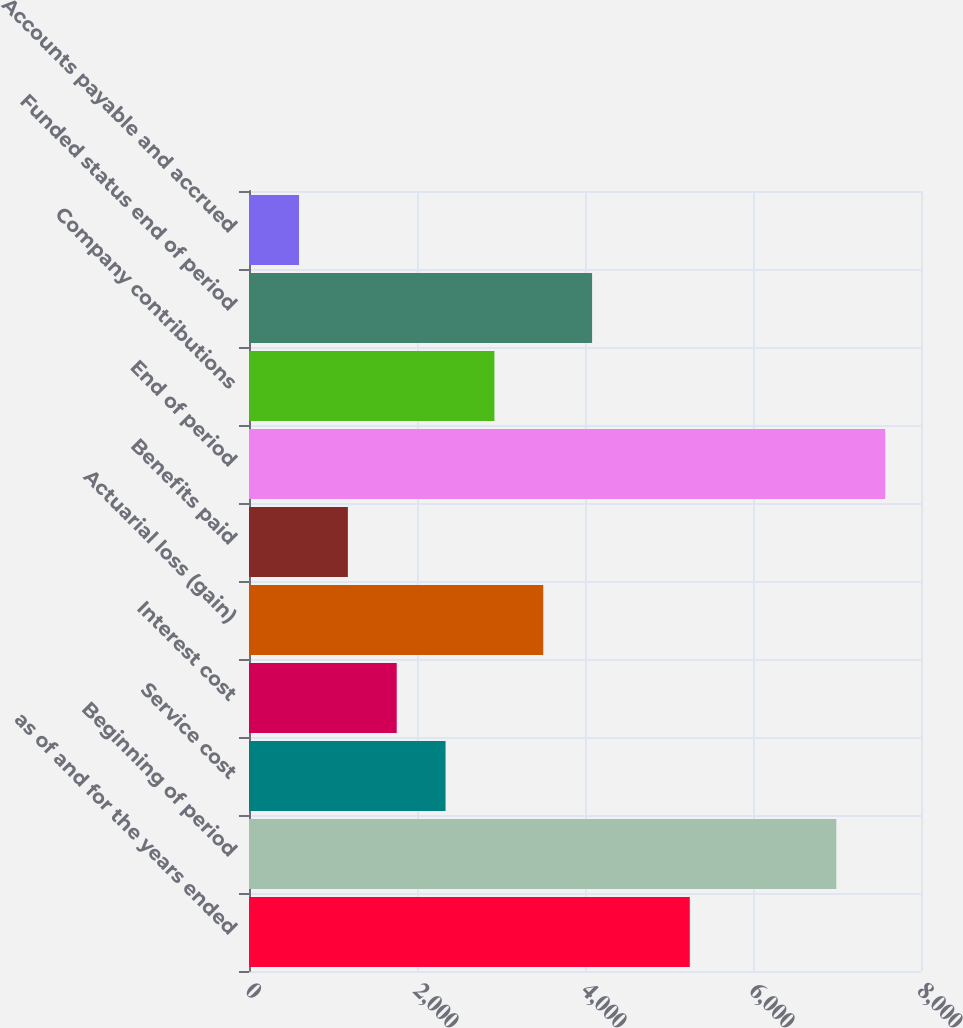Convert chart. <chart><loc_0><loc_0><loc_500><loc_500><bar_chart><fcel>as of and for the years ended<fcel>Beginning of period<fcel>Service cost<fcel>Interest cost<fcel>Actuarial loss (gain)<fcel>Benefits paid<fcel>End of period<fcel>Company contributions<fcel>Funded status end of period<fcel>Accounts payable and accrued<nl><fcel>5247.5<fcel>6992<fcel>2340<fcel>1758.5<fcel>3503<fcel>1177<fcel>7573.5<fcel>2921.5<fcel>4084.5<fcel>595.5<nl></chart> 